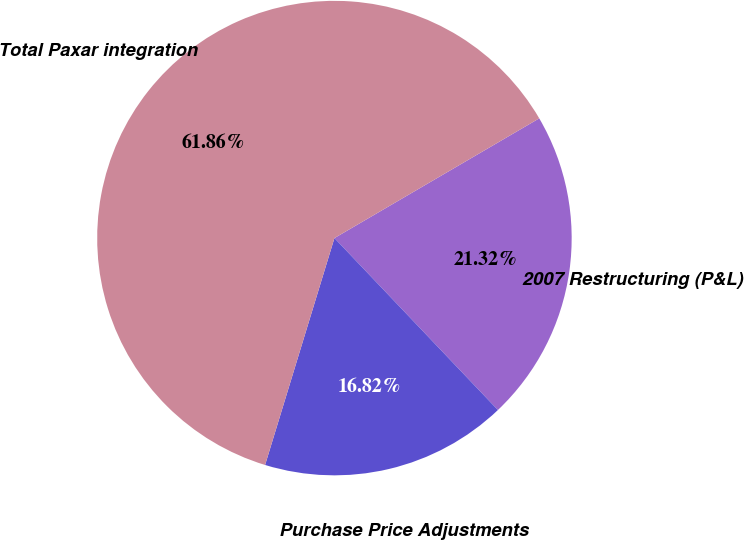Convert chart. <chart><loc_0><loc_0><loc_500><loc_500><pie_chart><fcel>2007 Restructuring (P&L)<fcel>Purchase Price Adjustments<fcel>Total Paxar integration<nl><fcel>21.32%<fcel>16.82%<fcel>61.86%<nl></chart> 